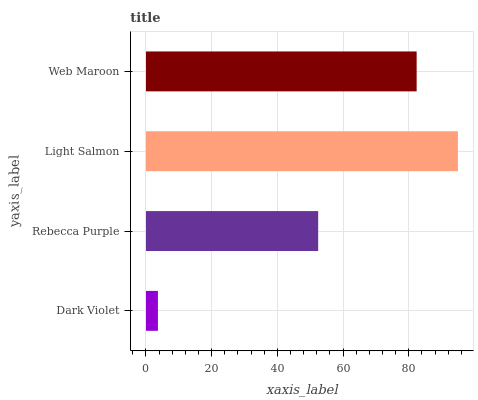Is Dark Violet the minimum?
Answer yes or no. Yes. Is Light Salmon the maximum?
Answer yes or no. Yes. Is Rebecca Purple the minimum?
Answer yes or no. No. Is Rebecca Purple the maximum?
Answer yes or no. No. Is Rebecca Purple greater than Dark Violet?
Answer yes or no. Yes. Is Dark Violet less than Rebecca Purple?
Answer yes or no. Yes. Is Dark Violet greater than Rebecca Purple?
Answer yes or no. No. Is Rebecca Purple less than Dark Violet?
Answer yes or no. No. Is Web Maroon the high median?
Answer yes or no. Yes. Is Rebecca Purple the low median?
Answer yes or no. Yes. Is Light Salmon the high median?
Answer yes or no. No. Is Dark Violet the low median?
Answer yes or no. No. 